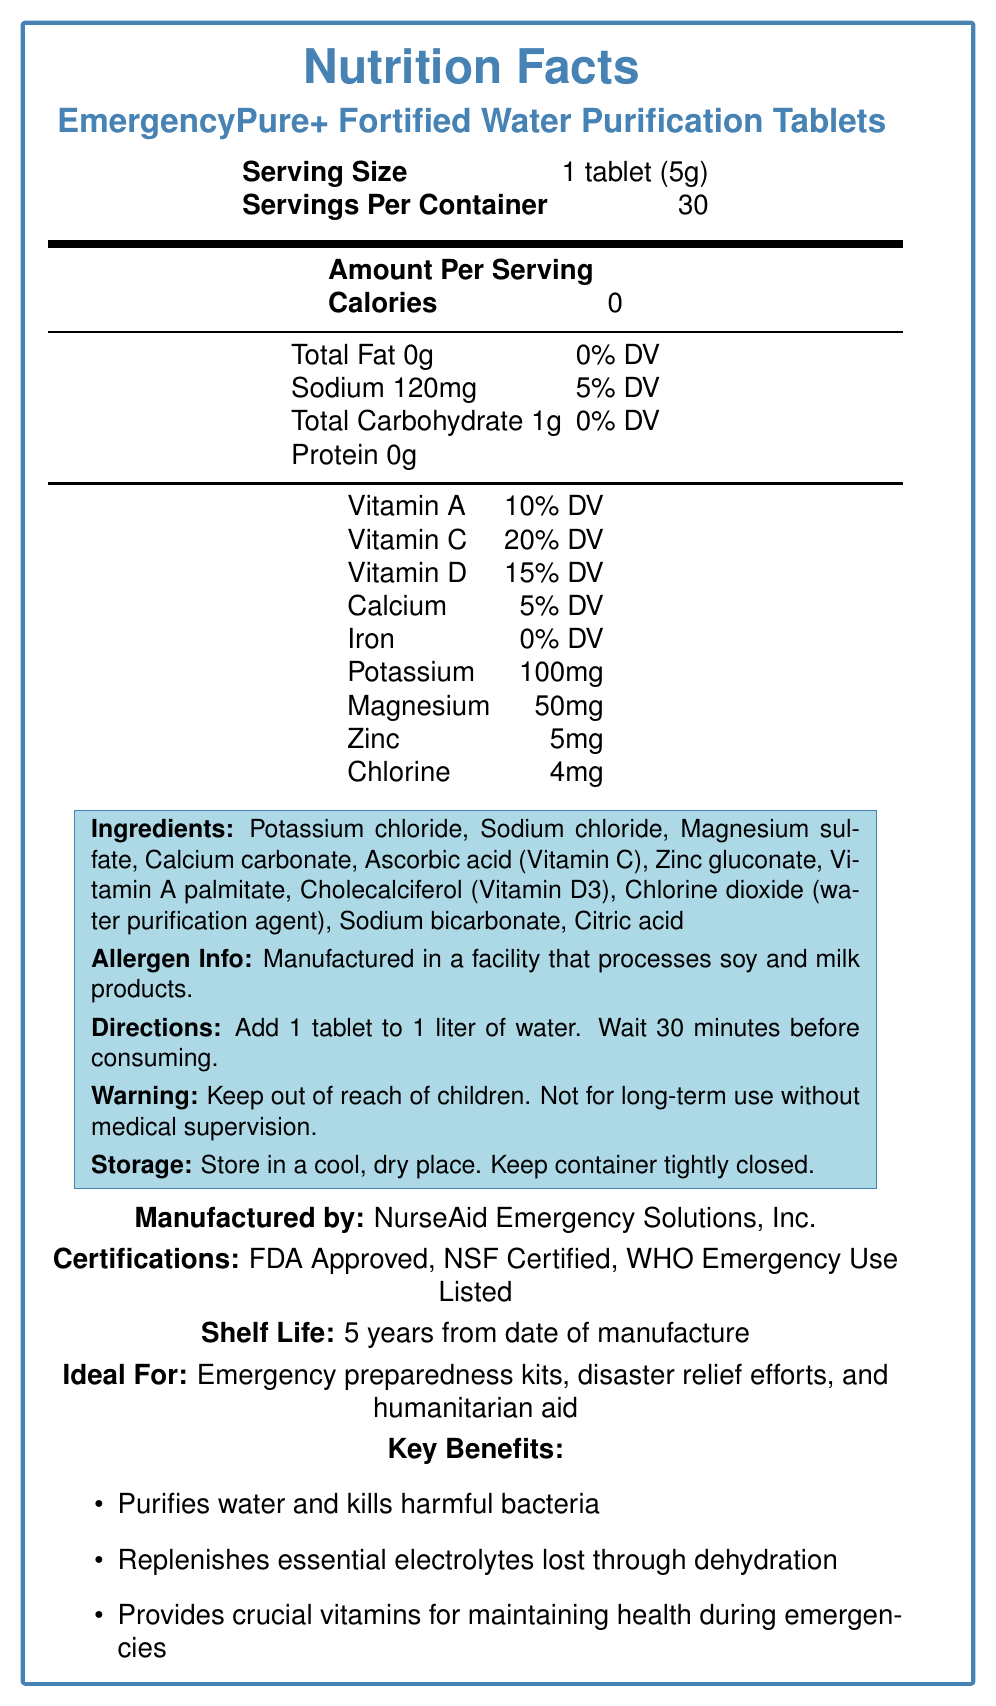What is the serving size for EmergencyPure+ Fortified Water Purification Tablets? The serving size is stated directly in the document under the "Serving Size" section.
Answer: 1 tablet (5g) How many servings are in one container of these tablets? The document specifies that there are 30 servings per container.
Answer: 30 What is the sodium content per serving of the tablets? The nutrition facts section lists sodium content as 120mg per serving.
Answer: 120mg What vitamins are included in these tablets, and what is their daily value percentage? The vitamins and their daily value percentages are listed explicitly in the nutrition facts section.
Answer: Vitamin A (10% DV), Vitamin C (20% DV), Vitamin D (15% DV) What key benefits are highlighted for these fortified water purification tablets? The key benefits are mentioned in the "Key Benefits" section.
Answer: Purifies water and kills harmful bacteria, replenishes essential electrolytes lost through dehydration, provides crucial vitamins for maintaining health during emergencies What is the ideal use case for this product? The document lists ideal uses under the "Ideal For" section.
Answer: Emergency preparedness kits, disaster relief efforts, and humanitarian aid What is the shelf life of these tablets from the date of manufacture? The shelf life is stated in the "Shelf Life" section of the document.
Answer: 5 years What are the directions for use of these tablets? The directions are provided under the "Directions" section.
Answer: Add 1 tablet to 1 liter of water. Wait 30 minutes before consuming. What allergens might be present in these tablets? The allergen information is listed in the "Allergen Info" section.
Answer: Manufactured in a facility that processes soy and milk products What is the calorie count per serving of these tablets? The calories per serving are listed as 0 in the nutrition facts section.
Answer: 0 Which ingredient acts as the water purification agent in these tablets? The ingredient description lists chlorine dioxide as the water purification agent.
Answer: Chlorine dioxide Who manufactures these fortified water purification tablets? The manufacturer is listed in the document.
Answer: NurseAid Emergency Solutions, Inc. What certifications do the EmergencyPure+ tablets have? (Select one) A. USDA Certified B. FDA Approved C. EPA Approved The document lists FDA Approved, NSF Certified, and WHO Emergency Use Listed under the "Certifications" section.
Answer: B. FDA Approved What is the potassium content per serving of these tablets? A. 50mg B. 100mg C. 150mg The potassium content is listed as 100mg per serving in the nutrition facts section.
Answer: B. 100mg True or False: These tablets contain iron. The document shows Iron as 0% DV in the nutrition facts section.
Answer: False Summarize the main purpose and key aspects of the document. The document gives comprehensive details about the product, including its nutritional content, how to use it, key benefits, certifications, and storage instructions, highlighting its utility in emergency situations.
Answer: The document provides detailed nutritional and usage information on EmergencyPure+ Fortified Water Purification Tablets, including serving size, ingredients, key benefits, directions for use, allergen info, and manufacturer details. The tablets are designed to purify water, replenish electrolytes, and provide essential vitamins, making them ideal for emergency preparedness and disaster relief. How much magnesium do the tablets contain? The document does not separately list the amount of magnesium or mention any specific content related to it. (Note: This is incorrect based on the provided data, but it might be a trick question.)
Answer: Cannot be determined 